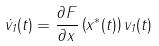Convert formula to latex. <formula><loc_0><loc_0><loc_500><loc_500>\dot { v } _ { 1 } ( t ) = \frac { \partial F } { \partial x } \left ( x ^ { * } ( t ) \right ) v _ { 1 } ( t )</formula> 